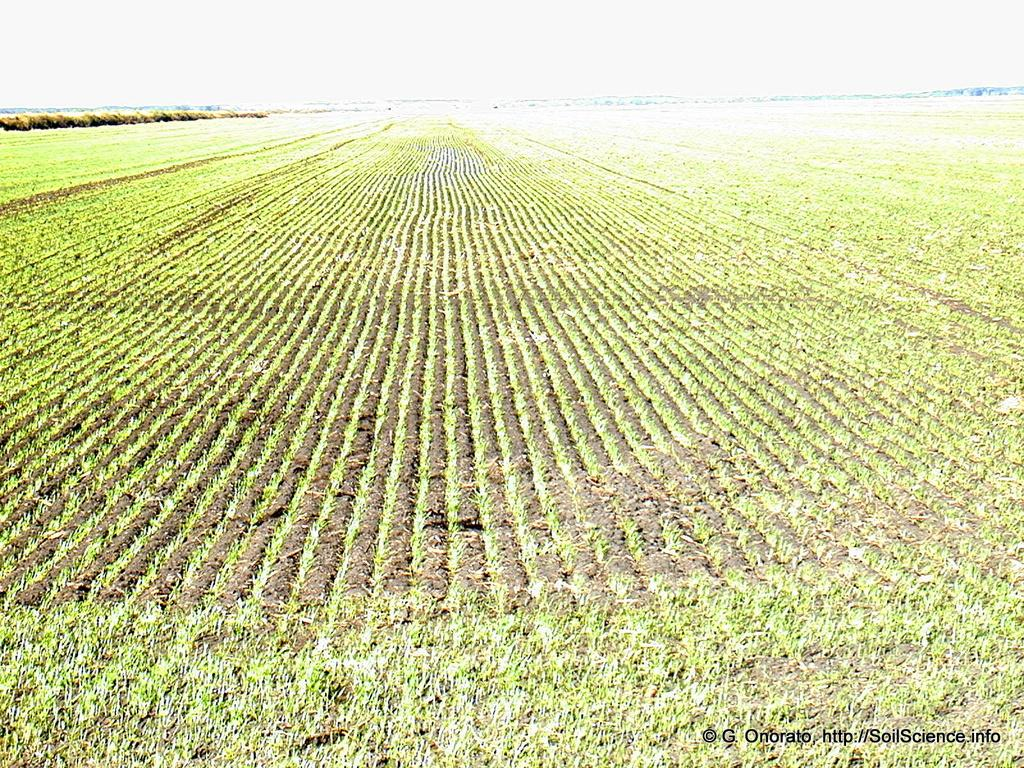What type of landscape can be seen in the image? There are fields visible in the image. Is there any text present in the image? Yes, there is text at the bottom of the image. Can you see any firemen or fire trucks in the image? No, there are no firemen or fire trucks present in the image. Are there any toys visible in the fields? No, there are no toys visible in the fields; only fields can be seen in the image. 